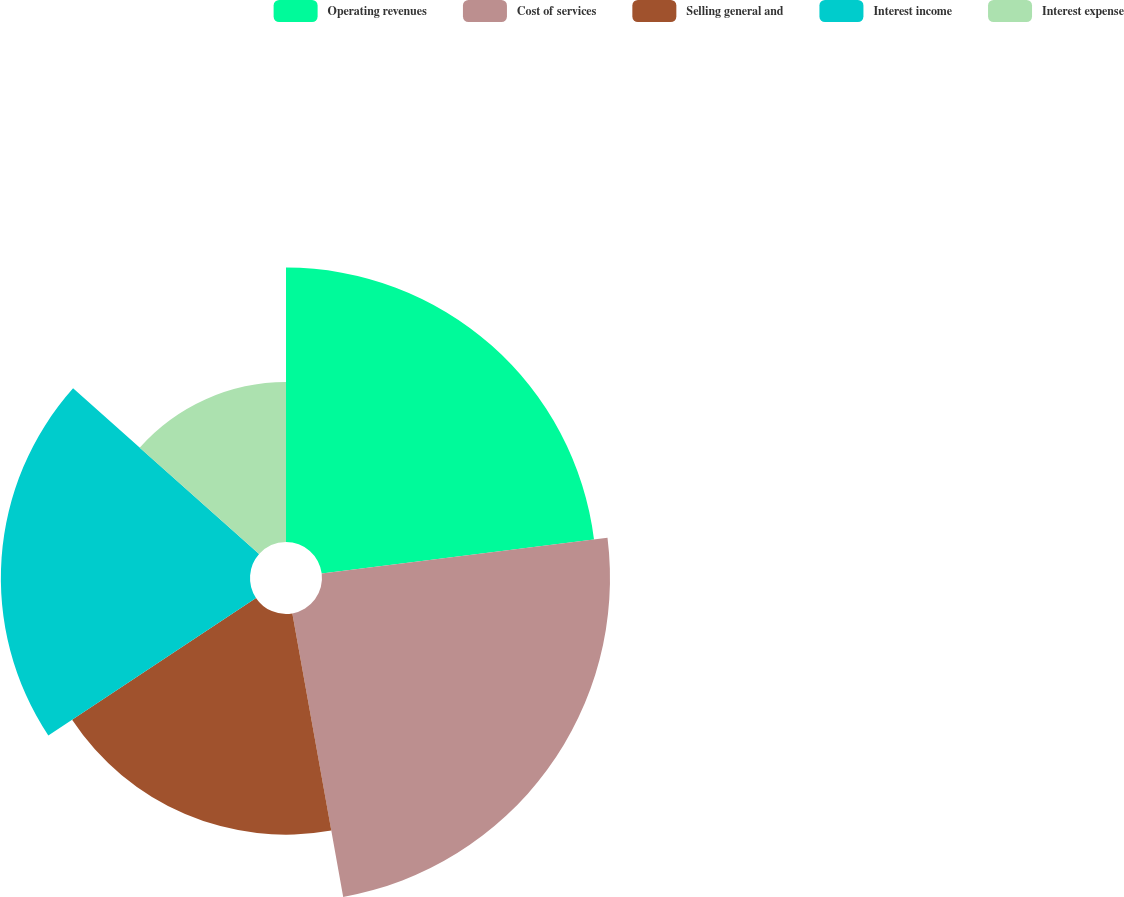<chart> <loc_0><loc_0><loc_500><loc_500><pie_chart><fcel>Operating revenues<fcel>Cost of services<fcel>Selling general and<fcel>Interest income<fcel>Interest expense<nl><fcel>23.02%<fcel>24.16%<fcel>18.51%<fcel>20.9%<fcel>13.42%<nl></chart> 